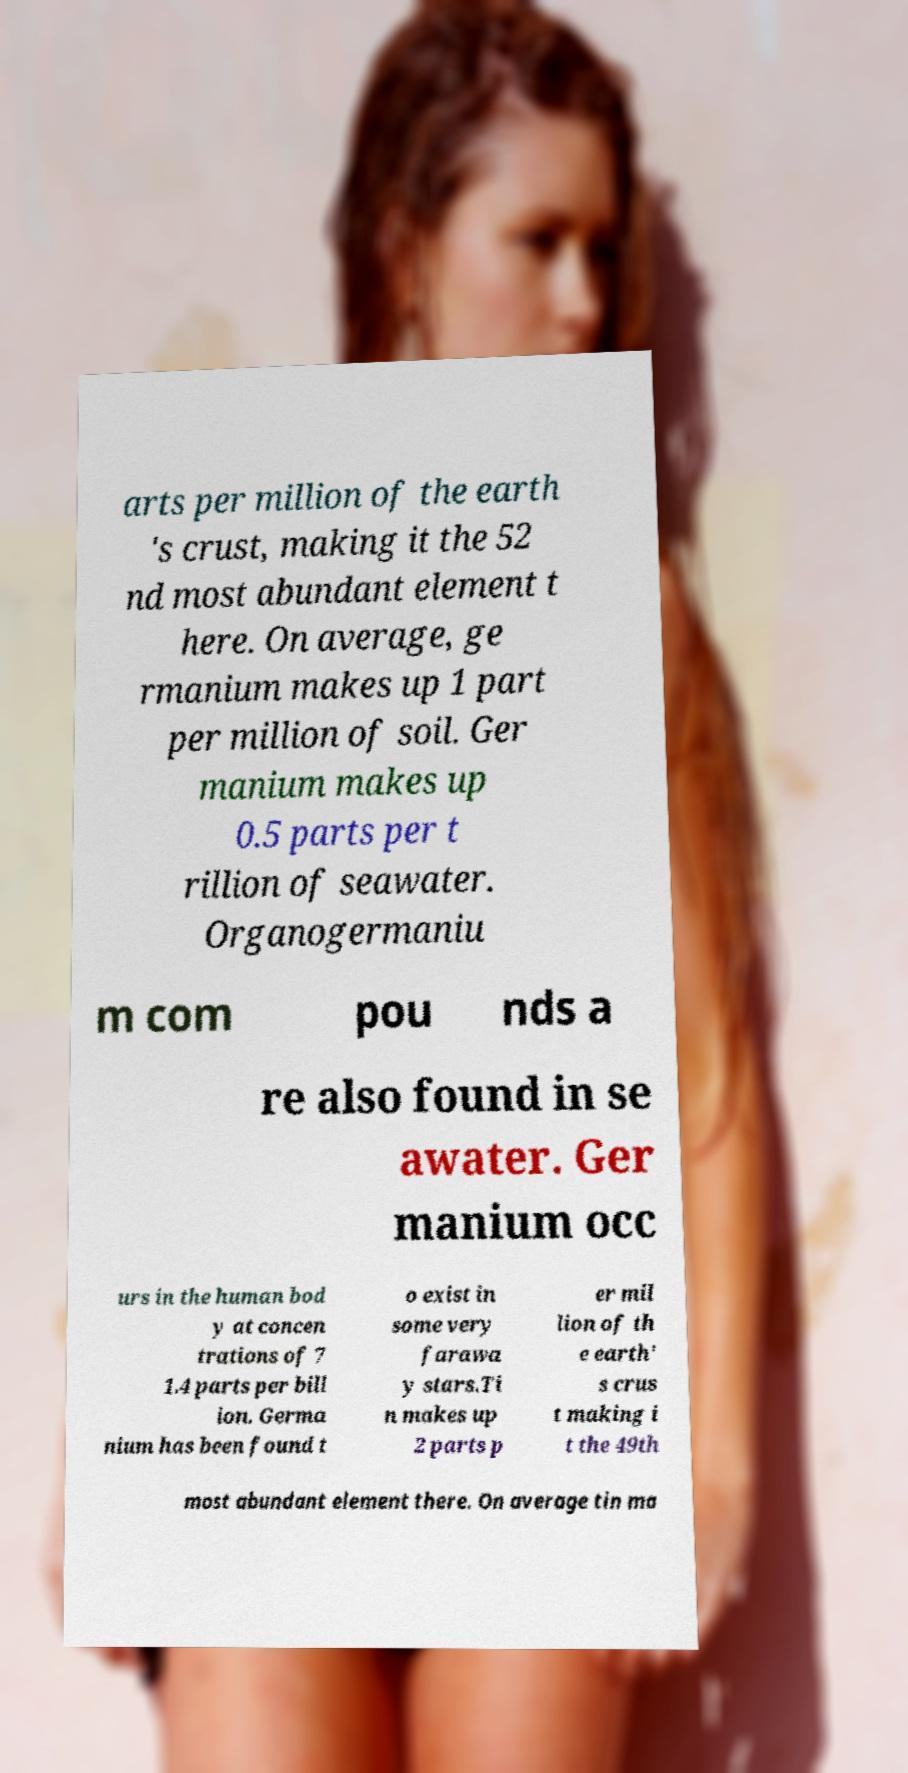There's text embedded in this image that I need extracted. Can you transcribe it verbatim? arts per million of the earth 's crust, making it the 52 nd most abundant element t here. On average, ge rmanium makes up 1 part per million of soil. Ger manium makes up 0.5 parts per t rillion of seawater. Organogermaniu m com pou nds a re also found in se awater. Ger manium occ urs in the human bod y at concen trations of 7 1.4 parts per bill ion. Germa nium has been found t o exist in some very farawa y stars.Ti n makes up 2 parts p er mil lion of th e earth' s crus t making i t the 49th most abundant element there. On average tin ma 